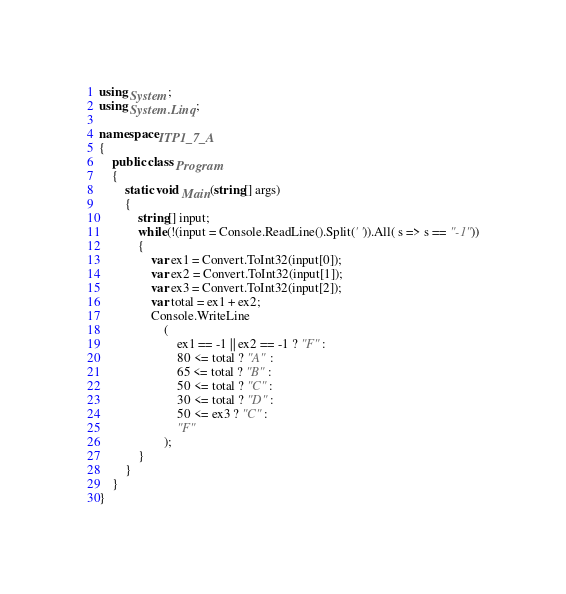Convert code to text. <code><loc_0><loc_0><loc_500><loc_500><_C#_>using System;
using System.Linq;

namespace ITP1_7_A
{
    public class Program
    {
        static void Main(string[] args)
        {
            string[] input;
            while(!(input = Console.ReadLine().Split(' ')).All( s => s == "-1"))
            {
                var ex1 = Convert.ToInt32(input[0]);
                var ex2 = Convert.ToInt32(input[1]);
                var ex3 = Convert.ToInt32(input[2]);
                var total = ex1 + ex2;
                Console.WriteLine
                    (
                        ex1 == -1 || ex2 == -1 ? "F" :
                        80 <= total ? "A" :
                        65 <= total ? "B" :
                        50 <= total ? "C" :
                        30 <= total ? "D" :
                        50 <= ex3 ? "C" :
                        "F"
                    );
            }
        }
    }
}</code> 